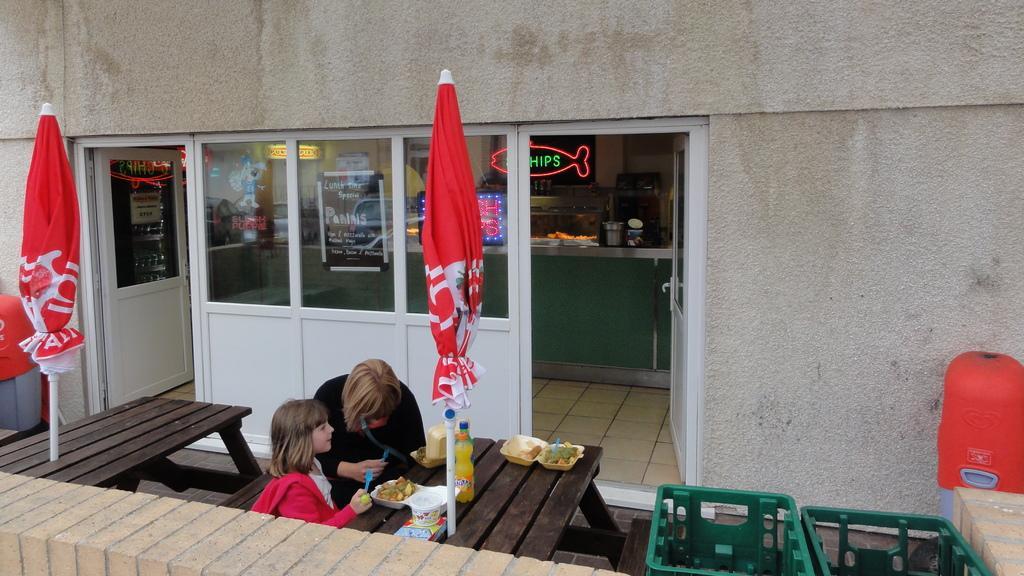Describe this image in one or two sentences. In this picture there is a woman who is wearing black dress, beside her there is a girl who is holding a spoon. Both of them are sitting on the bench near to the table. On the table I can see the umbrella, juice bottles, water bottle, caps, plastic covers and other food items. In the back I can see the doors. On the left there is a dustbin which is placed near to the table, bench and door. Through the door I can see the platform and electronic item. On the platform I can see some objects, behind the table I can see the board which is placed on on the wall and its looks like a fish. In the bottom right corner I can see the dustbins. 